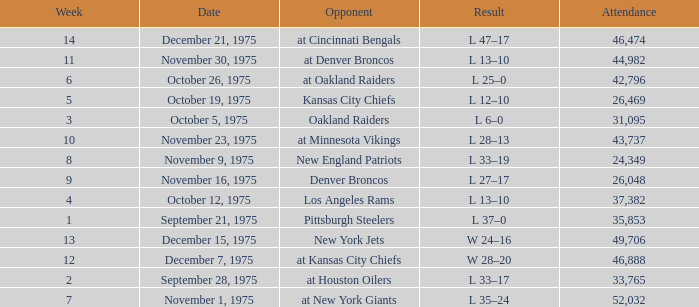What is the highest Week when the opponent was the los angeles rams, with more than 37,382 in Attendance? None. 